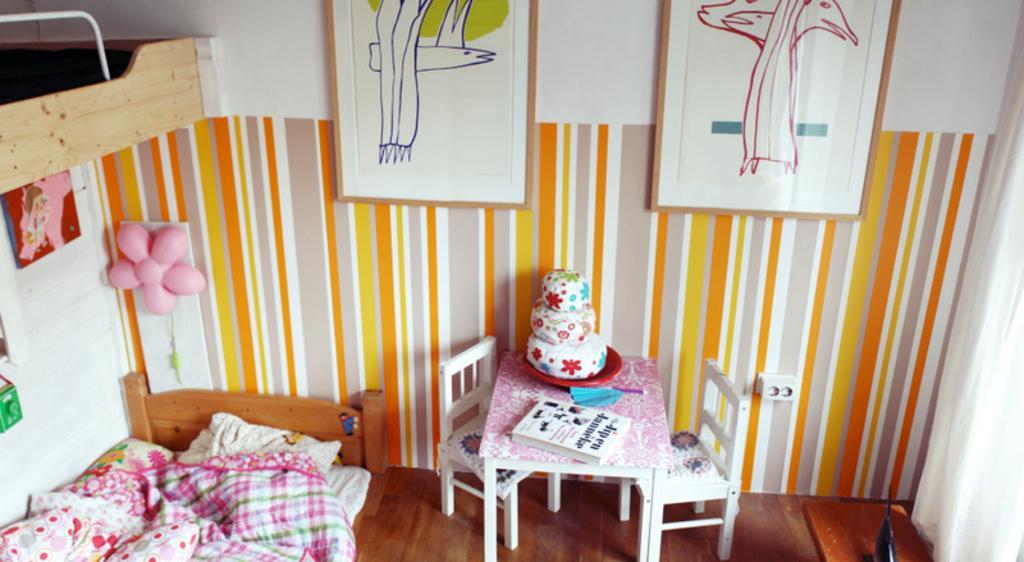In one or two sentences, can you explain what this image depicts? In the picture we can see some room, inside it, we can see a wall with paintings and we can also see some photo frames and on the floor, we can see a table and chairs which are white in color and besides we can see a bed with pillows and bed sheet. 